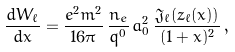<formula> <loc_0><loc_0><loc_500><loc_500>\frac { d W _ { \ell } } { d x } = \frac { e ^ { 2 } m ^ { 2 } } { 1 6 \pi } \, \frac { n _ { e } } { q ^ { 0 } } \, a _ { 0 } ^ { 2 } \, \frac { \mathfrak { J } _ { \ell } ( z _ { \ell } ( x ) ) } { ( 1 + x ) ^ { 2 } } \, ,</formula> 